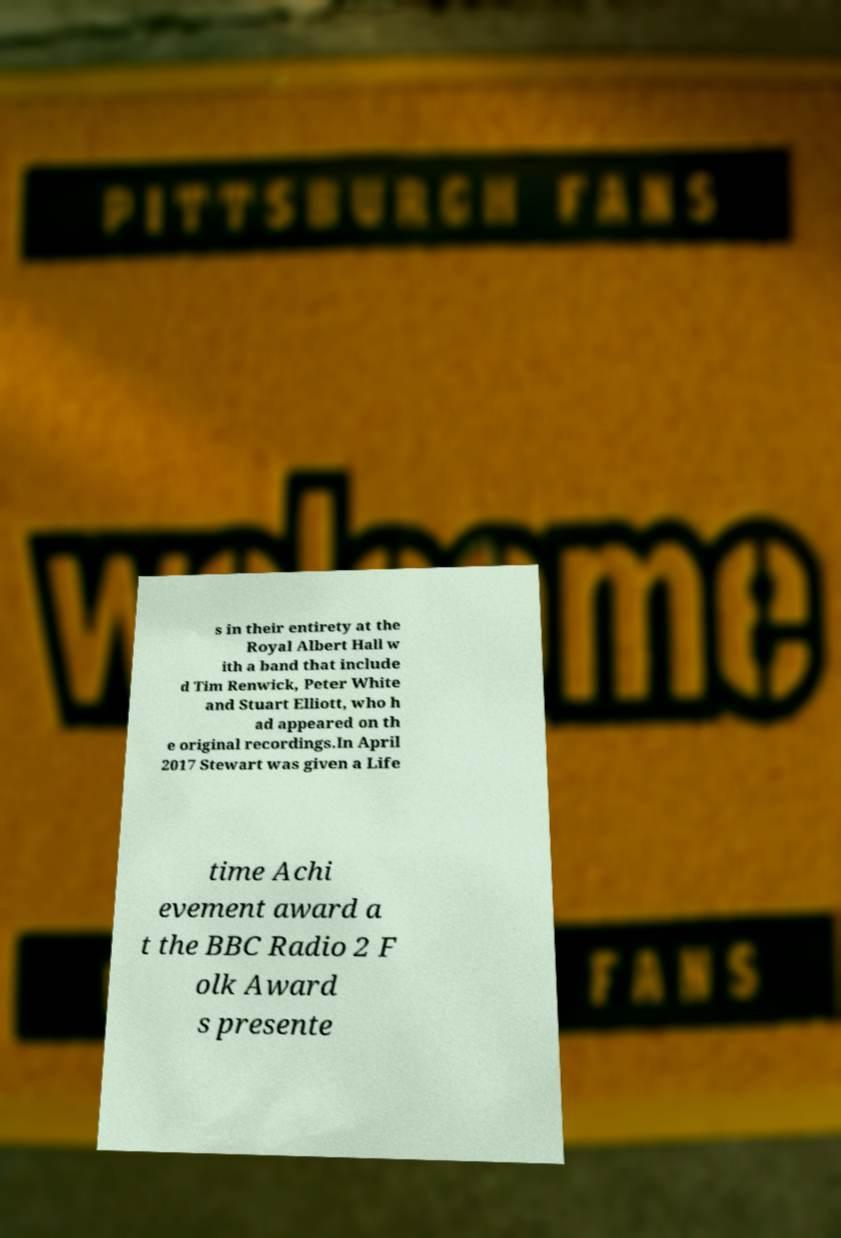What messages or text are displayed in this image? I need them in a readable, typed format. s in their entirety at the Royal Albert Hall w ith a band that include d Tim Renwick, Peter White and Stuart Elliott, who h ad appeared on th e original recordings.In April 2017 Stewart was given a Life time Achi evement award a t the BBC Radio 2 F olk Award s presente 